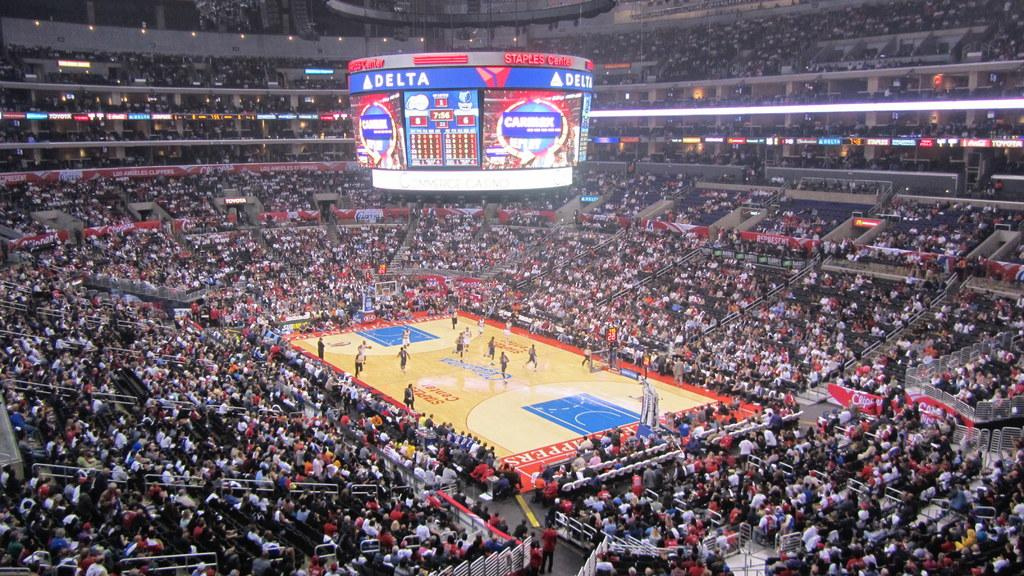<image>
Write a terse but informative summary of the picture. A basketball game is being played at the Delta arena. 